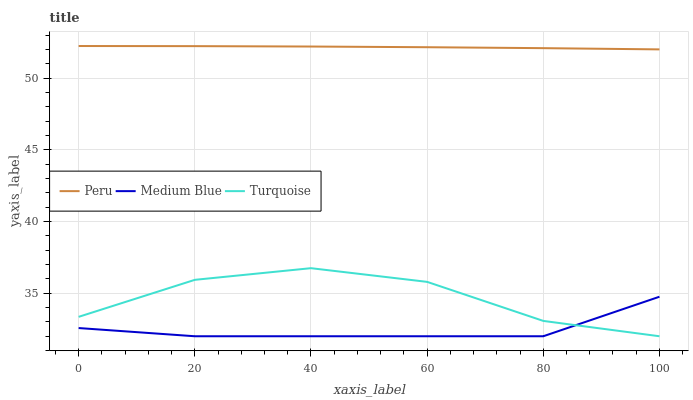Does Peru have the minimum area under the curve?
Answer yes or no. No. Does Medium Blue have the maximum area under the curve?
Answer yes or no. No. Is Medium Blue the smoothest?
Answer yes or no. No. Is Medium Blue the roughest?
Answer yes or no. No. Does Peru have the lowest value?
Answer yes or no. No. Does Medium Blue have the highest value?
Answer yes or no. No. Is Turquoise less than Peru?
Answer yes or no. Yes. Is Peru greater than Turquoise?
Answer yes or no. Yes. Does Turquoise intersect Peru?
Answer yes or no. No. 